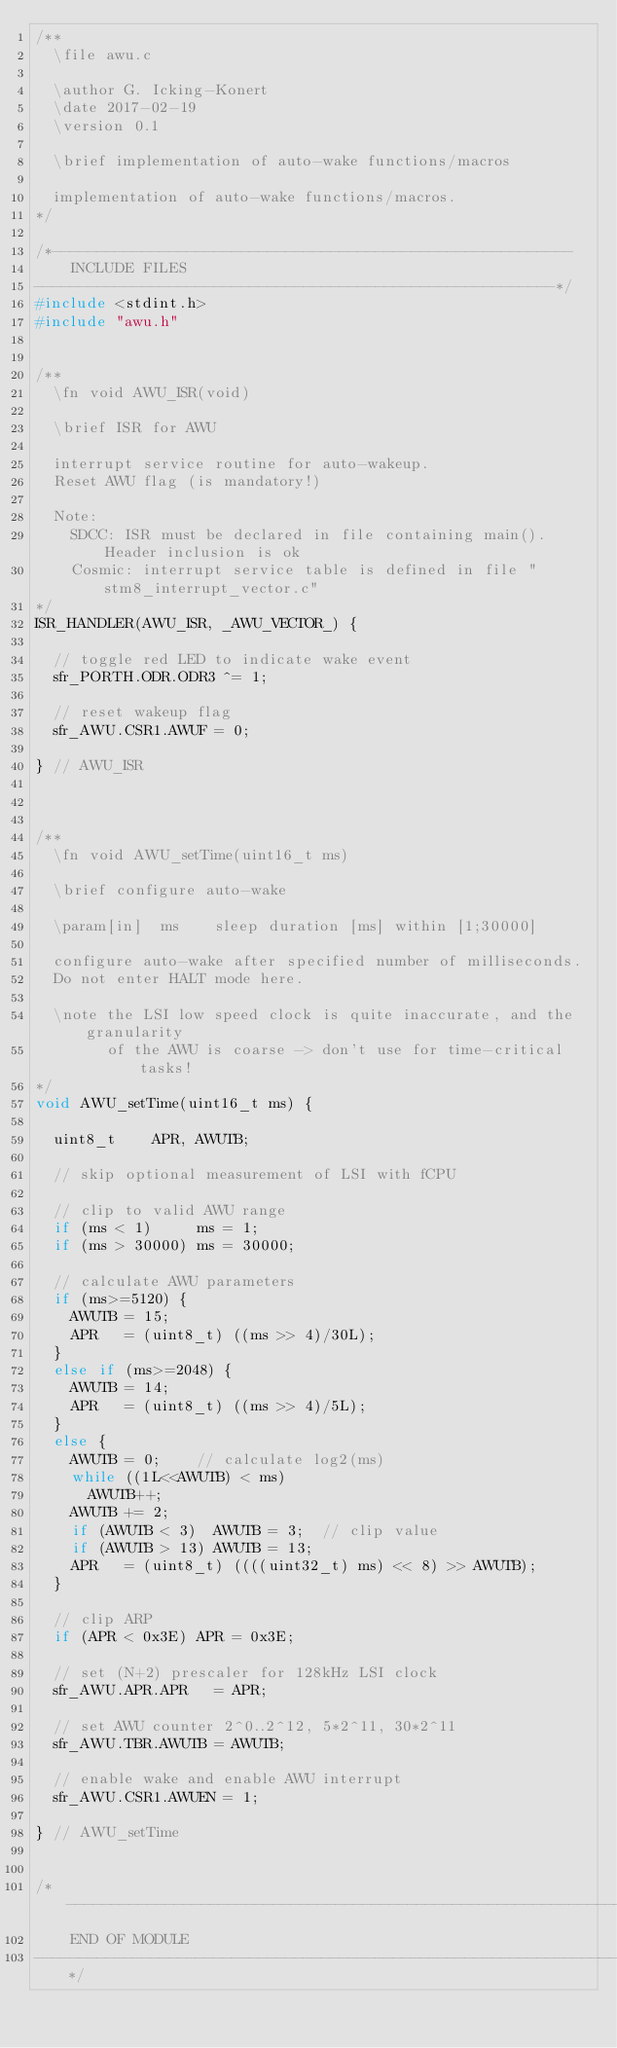Convert code to text. <code><loc_0><loc_0><loc_500><loc_500><_C_>/**
  \file awu.c
   
  \author G. Icking-Konert
  \date 2017-02-19
  \version 0.1
   
  \brief implementation of auto-wake functions/macros
   
  implementation of auto-wake functions/macros.
*/

/*----------------------------------------------------------
    INCLUDE FILES
----------------------------------------------------------*/
#include <stdint.h>
#include "awu.h"


/**
  \fn void AWU_ISR(void)
   
  \brief ISR for AWU
   
  interrupt service routine for auto-wakeup.
  Reset AWU flag (is mandatory!)

  Note: 
    SDCC: ISR must be declared in file containing main(). Header inclusion is ok
    Cosmic: interrupt service table is defined in file "stm8_interrupt_vector.c"
*/
ISR_HANDLER(AWU_ISR, _AWU_VECTOR_) {

  // toggle red LED to indicate wake event
  sfr_PORTH.ODR.ODR3 ^= 1;
  
  // reset wakeup flag
  sfr_AWU.CSR1.AWUF = 0;
  
} // AWU_ISR



/**
  \fn void AWU_setTime(uint16_t ms)
   
  \brief configure auto-wake
  
  \param[in]  ms    sleep duration [ms] within [1;30000]
  
  configure auto-wake after specified number of milliseconds.
  Do not enter HALT mode here.

  \note the LSI low speed clock is quite inaccurate, and the granularity
        of the AWU is coarse -> don't use for time-critical tasks!
*/
void AWU_setTime(uint16_t ms) {

  uint8_t    APR, AWUTB;

  // skip optional measurement of LSI with fCPU

  // clip to valid AWU range
  if (ms < 1)     ms = 1;
  if (ms > 30000) ms = 30000;

  // calculate AWU parameters
  if (ms>=5120) {
    AWUTB = 15;
    APR   = (uint8_t) ((ms >> 4)/30L);
  }
  else if (ms>=2048) {
    AWUTB = 14;
    APR   = (uint8_t) ((ms >> 4)/5L);
  }
  else {
    AWUTB = 0;    // calculate log2(ms)
    while ((1L<<AWUTB) < ms)
      AWUTB++;
    AWUTB += 2;
    if (AWUTB < 3)  AWUTB = 3;  // clip value
    if (AWUTB > 13) AWUTB = 13;
    APR   = (uint8_t) ((((uint32_t) ms) << 8) >> AWUTB);
  }
  
  // clip ARP
  if (APR < 0x3E) APR = 0x3E;

  // set (N+2) prescaler for 128kHz LSI clock
  sfr_AWU.APR.APR   = APR;
  
  // set AWU counter 2^0..2^12, 5*2^11, 30*2^11
  sfr_AWU.TBR.AWUTB = AWUTB;
  
  // enable wake and enable AWU interrupt
  sfr_AWU.CSR1.AWUEN = 1;
  
} // AWU_setTime


/*-----------------------------------------------------------------------------
    END OF MODULE
-----------------------------------------------------------------------------*/
</code> 